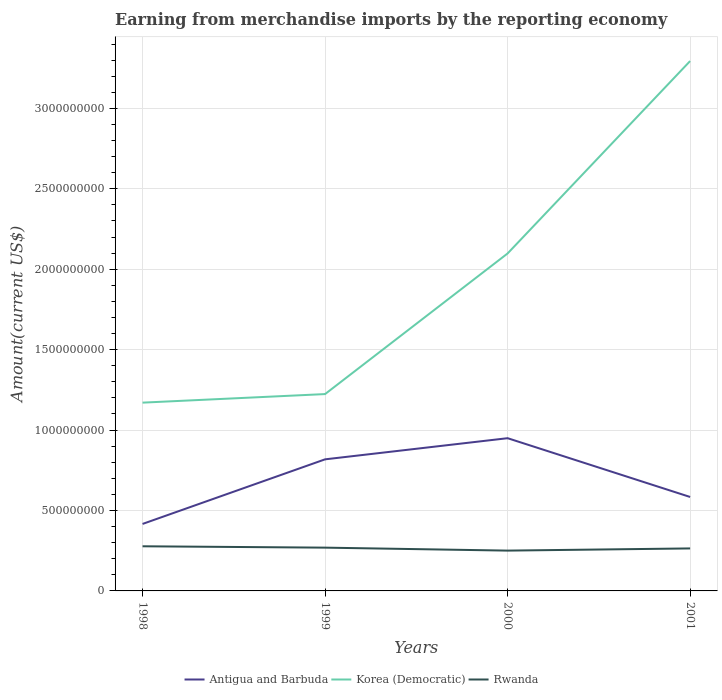How many different coloured lines are there?
Your answer should be compact. 3. Does the line corresponding to Antigua and Barbuda intersect with the line corresponding to Korea (Democratic)?
Your response must be concise. No. Across all years, what is the maximum amount earned from merchandise imports in Antigua and Barbuda?
Provide a short and direct response. 4.16e+08. In which year was the amount earned from merchandise imports in Antigua and Barbuda maximum?
Give a very brief answer. 1998. What is the total amount earned from merchandise imports in Korea (Democratic) in the graph?
Ensure brevity in your answer.  -1.20e+09. What is the difference between the highest and the second highest amount earned from merchandise imports in Korea (Democratic)?
Ensure brevity in your answer.  2.12e+09. What is the difference between the highest and the lowest amount earned from merchandise imports in Korea (Democratic)?
Ensure brevity in your answer.  2. Is the amount earned from merchandise imports in Korea (Democratic) strictly greater than the amount earned from merchandise imports in Antigua and Barbuda over the years?
Provide a succinct answer. No. How many years are there in the graph?
Your answer should be compact. 4. What is the difference between two consecutive major ticks on the Y-axis?
Your answer should be very brief. 5.00e+08. Are the values on the major ticks of Y-axis written in scientific E-notation?
Make the answer very short. No. Does the graph contain any zero values?
Your answer should be compact. No. Does the graph contain grids?
Your answer should be very brief. Yes. How many legend labels are there?
Provide a short and direct response. 3. How are the legend labels stacked?
Your answer should be compact. Horizontal. What is the title of the graph?
Provide a succinct answer. Earning from merchandise imports by the reporting economy. Does "Azerbaijan" appear as one of the legend labels in the graph?
Your answer should be compact. No. What is the label or title of the Y-axis?
Offer a terse response. Amount(current US$). What is the Amount(current US$) of Antigua and Barbuda in 1998?
Offer a terse response. 4.16e+08. What is the Amount(current US$) in Korea (Democratic) in 1998?
Provide a short and direct response. 1.17e+09. What is the Amount(current US$) of Rwanda in 1998?
Provide a succinct answer. 2.78e+08. What is the Amount(current US$) of Antigua and Barbuda in 1999?
Give a very brief answer. 8.18e+08. What is the Amount(current US$) of Korea (Democratic) in 1999?
Provide a succinct answer. 1.22e+09. What is the Amount(current US$) of Rwanda in 1999?
Your answer should be very brief. 2.69e+08. What is the Amount(current US$) of Antigua and Barbuda in 2000?
Keep it short and to the point. 9.50e+08. What is the Amount(current US$) of Korea (Democratic) in 2000?
Make the answer very short. 2.10e+09. What is the Amount(current US$) in Rwanda in 2000?
Offer a terse response. 2.51e+08. What is the Amount(current US$) of Antigua and Barbuda in 2001?
Provide a succinct answer. 5.84e+08. What is the Amount(current US$) of Korea (Democratic) in 2001?
Ensure brevity in your answer.  3.29e+09. What is the Amount(current US$) of Rwanda in 2001?
Offer a terse response. 2.64e+08. Across all years, what is the maximum Amount(current US$) in Antigua and Barbuda?
Offer a terse response. 9.50e+08. Across all years, what is the maximum Amount(current US$) of Korea (Democratic)?
Your answer should be compact. 3.29e+09. Across all years, what is the maximum Amount(current US$) of Rwanda?
Provide a short and direct response. 2.78e+08. Across all years, what is the minimum Amount(current US$) in Antigua and Barbuda?
Ensure brevity in your answer.  4.16e+08. Across all years, what is the minimum Amount(current US$) of Korea (Democratic)?
Your answer should be compact. 1.17e+09. Across all years, what is the minimum Amount(current US$) of Rwanda?
Provide a short and direct response. 2.51e+08. What is the total Amount(current US$) in Antigua and Barbuda in the graph?
Ensure brevity in your answer.  2.77e+09. What is the total Amount(current US$) of Korea (Democratic) in the graph?
Your response must be concise. 7.79e+09. What is the total Amount(current US$) of Rwanda in the graph?
Provide a succinct answer. 1.06e+09. What is the difference between the Amount(current US$) of Antigua and Barbuda in 1998 and that in 1999?
Offer a terse response. -4.02e+08. What is the difference between the Amount(current US$) of Korea (Democratic) in 1998 and that in 1999?
Keep it short and to the point. -5.33e+07. What is the difference between the Amount(current US$) of Rwanda in 1998 and that in 1999?
Offer a terse response. 8.50e+06. What is the difference between the Amount(current US$) of Antigua and Barbuda in 1998 and that in 2000?
Your response must be concise. -5.33e+08. What is the difference between the Amount(current US$) of Korea (Democratic) in 1998 and that in 2000?
Provide a short and direct response. -9.28e+08. What is the difference between the Amount(current US$) in Rwanda in 1998 and that in 2000?
Your answer should be compact. 2.69e+07. What is the difference between the Amount(current US$) in Antigua and Barbuda in 1998 and that in 2001?
Your answer should be compact. -1.68e+08. What is the difference between the Amount(current US$) in Korea (Democratic) in 1998 and that in 2001?
Provide a short and direct response. -2.12e+09. What is the difference between the Amount(current US$) in Rwanda in 1998 and that in 2001?
Your response must be concise. 1.33e+07. What is the difference between the Amount(current US$) of Antigua and Barbuda in 1999 and that in 2000?
Keep it short and to the point. -1.31e+08. What is the difference between the Amount(current US$) in Korea (Democratic) in 1999 and that in 2000?
Your response must be concise. -8.74e+08. What is the difference between the Amount(current US$) in Rwanda in 1999 and that in 2000?
Ensure brevity in your answer.  1.84e+07. What is the difference between the Amount(current US$) in Antigua and Barbuda in 1999 and that in 2001?
Offer a very short reply. 2.34e+08. What is the difference between the Amount(current US$) of Korea (Democratic) in 1999 and that in 2001?
Your answer should be very brief. -2.07e+09. What is the difference between the Amount(current US$) of Rwanda in 1999 and that in 2001?
Your response must be concise. 4.82e+06. What is the difference between the Amount(current US$) of Antigua and Barbuda in 2000 and that in 2001?
Offer a very short reply. 3.65e+08. What is the difference between the Amount(current US$) of Korea (Democratic) in 2000 and that in 2001?
Provide a short and direct response. -1.20e+09. What is the difference between the Amount(current US$) of Rwanda in 2000 and that in 2001?
Keep it short and to the point. -1.36e+07. What is the difference between the Amount(current US$) in Antigua and Barbuda in 1998 and the Amount(current US$) in Korea (Democratic) in 1999?
Give a very brief answer. -8.07e+08. What is the difference between the Amount(current US$) in Antigua and Barbuda in 1998 and the Amount(current US$) in Rwanda in 1999?
Make the answer very short. 1.47e+08. What is the difference between the Amount(current US$) of Korea (Democratic) in 1998 and the Amount(current US$) of Rwanda in 1999?
Ensure brevity in your answer.  9.02e+08. What is the difference between the Amount(current US$) in Antigua and Barbuda in 1998 and the Amount(current US$) in Korea (Democratic) in 2000?
Ensure brevity in your answer.  -1.68e+09. What is the difference between the Amount(current US$) of Antigua and Barbuda in 1998 and the Amount(current US$) of Rwanda in 2000?
Make the answer very short. 1.66e+08. What is the difference between the Amount(current US$) of Korea (Democratic) in 1998 and the Amount(current US$) of Rwanda in 2000?
Your response must be concise. 9.20e+08. What is the difference between the Amount(current US$) of Antigua and Barbuda in 1998 and the Amount(current US$) of Korea (Democratic) in 2001?
Offer a very short reply. -2.88e+09. What is the difference between the Amount(current US$) of Antigua and Barbuda in 1998 and the Amount(current US$) of Rwanda in 2001?
Provide a succinct answer. 1.52e+08. What is the difference between the Amount(current US$) of Korea (Democratic) in 1998 and the Amount(current US$) of Rwanda in 2001?
Make the answer very short. 9.06e+08. What is the difference between the Amount(current US$) of Antigua and Barbuda in 1999 and the Amount(current US$) of Korea (Democratic) in 2000?
Your answer should be compact. -1.28e+09. What is the difference between the Amount(current US$) in Antigua and Barbuda in 1999 and the Amount(current US$) in Rwanda in 2000?
Your answer should be compact. 5.67e+08. What is the difference between the Amount(current US$) in Korea (Democratic) in 1999 and the Amount(current US$) in Rwanda in 2000?
Give a very brief answer. 9.73e+08. What is the difference between the Amount(current US$) of Antigua and Barbuda in 1999 and the Amount(current US$) of Korea (Democratic) in 2001?
Ensure brevity in your answer.  -2.48e+09. What is the difference between the Amount(current US$) of Antigua and Barbuda in 1999 and the Amount(current US$) of Rwanda in 2001?
Keep it short and to the point. 5.54e+08. What is the difference between the Amount(current US$) in Korea (Democratic) in 1999 and the Amount(current US$) in Rwanda in 2001?
Your answer should be compact. 9.60e+08. What is the difference between the Amount(current US$) of Antigua and Barbuda in 2000 and the Amount(current US$) of Korea (Democratic) in 2001?
Provide a short and direct response. -2.34e+09. What is the difference between the Amount(current US$) of Antigua and Barbuda in 2000 and the Amount(current US$) of Rwanda in 2001?
Your answer should be compact. 6.85e+08. What is the difference between the Amount(current US$) of Korea (Democratic) in 2000 and the Amount(current US$) of Rwanda in 2001?
Give a very brief answer. 1.83e+09. What is the average Amount(current US$) in Antigua and Barbuda per year?
Ensure brevity in your answer.  6.92e+08. What is the average Amount(current US$) in Korea (Democratic) per year?
Offer a very short reply. 1.95e+09. What is the average Amount(current US$) of Rwanda per year?
Keep it short and to the point. 2.65e+08. In the year 1998, what is the difference between the Amount(current US$) of Antigua and Barbuda and Amount(current US$) of Korea (Democratic)?
Keep it short and to the point. -7.54e+08. In the year 1998, what is the difference between the Amount(current US$) of Antigua and Barbuda and Amount(current US$) of Rwanda?
Ensure brevity in your answer.  1.39e+08. In the year 1998, what is the difference between the Amount(current US$) of Korea (Democratic) and Amount(current US$) of Rwanda?
Make the answer very short. 8.93e+08. In the year 1999, what is the difference between the Amount(current US$) of Antigua and Barbuda and Amount(current US$) of Korea (Democratic)?
Ensure brevity in your answer.  -4.06e+08. In the year 1999, what is the difference between the Amount(current US$) in Antigua and Barbuda and Amount(current US$) in Rwanda?
Your answer should be very brief. 5.49e+08. In the year 1999, what is the difference between the Amount(current US$) in Korea (Democratic) and Amount(current US$) in Rwanda?
Keep it short and to the point. 9.55e+08. In the year 2000, what is the difference between the Amount(current US$) of Antigua and Barbuda and Amount(current US$) of Korea (Democratic)?
Offer a very short reply. -1.15e+09. In the year 2000, what is the difference between the Amount(current US$) in Antigua and Barbuda and Amount(current US$) in Rwanda?
Provide a succinct answer. 6.99e+08. In the year 2000, what is the difference between the Amount(current US$) in Korea (Democratic) and Amount(current US$) in Rwanda?
Offer a very short reply. 1.85e+09. In the year 2001, what is the difference between the Amount(current US$) of Antigua and Barbuda and Amount(current US$) of Korea (Democratic)?
Your answer should be compact. -2.71e+09. In the year 2001, what is the difference between the Amount(current US$) of Antigua and Barbuda and Amount(current US$) of Rwanda?
Offer a very short reply. 3.20e+08. In the year 2001, what is the difference between the Amount(current US$) of Korea (Democratic) and Amount(current US$) of Rwanda?
Provide a succinct answer. 3.03e+09. What is the ratio of the Amount(current US$) of Antigua and Barbuda in 1998 to that in 1999?
Give a very brief answer. 0.51. What is the ratio of the Amount(current US$) of Korea (Democratic) in 1998 to that in 1999?
Provide a succinct answer. 0.96. What is the ratio of the Amount(current US$) in Rwanda in 1998 to that in 1999?
Give a very brief answer. 1.03. What is the ratio of the Amount(current US$) in Antigua and Barbuda in 1998 to that in 2000?
Keep it short and to the point. 0.44. What is the ratio of the Amount(current US$) of Korea (Democratic) in 1998 to that in 2000?
Provide a succinct answer. 0.56. What is the ratio of the Amount(current US$) of Rwanda in 1998 to that in 2000?
Make the answer very short. 1.11. What is the ratio of the Amount(current US$) of Antigua and Barbuda in 1998 to that in 2001?
Your answer should be compact. 0.71. What is the ratio of the Amount(current US$) in Korea (Democratic) in 1998 to that in 2001?
Keep it short and to the point. 0.36. What is the ratio of the Amount(current US$) of Rwanda in 1998 to that in 2001?
Your answer should be compact. 1.05. What is the ratio of the Amount(current US$) in Antigua and Barbuda in 1999 to that in 2000?
Make the answer very short. 0.86. What is the ratio of the Amount(current US$) of Korea (Democratic) in 1999 to that in 2000?
Your answer should be very brief. 0.58. What is the ratio of the Amount(current US$) in Rwanda in 1999 to that in 2000?
Provide a short and direct response. 1.07. What is the ratio of the Amount(current US$) of Antigua and Barbuda in 1999 to that in 2001?
Provide a short and direct response. 1.4. What is the ratio of the Amount(current US$) of Korea (Democratic) in 1999 to that in 2001?
Make the answer very short. 0.37. What is the ratio of the Amount(current US$) of Rwanda in 1999 to that in 2001?
Offer a terse response. 1.02. What is the ratio of the Amount(current US$) of Antigua and Barbuda in 2000 to that in 2001?
Provide a succinct answer. 1.63. What is the ratio of the Amount(current US$) in Korea (Democratic) in 2000 to that in 2001?
Offer a very short reply. 0.64. What is the ratio of the Amount(current US$) in Rwanda in 2000 to that in 2001?
Your response must be concise. 0.95. What is the difference between the highest and the second highest Amount(current US$) in Antigua and Barbuda?
Ensure brevity in your answer.  1.31e+08. What is the difference between the highest and the second highest Amount(current US$) of Korea (Democratic)?
Your response must be concise. 1.20e+09. What is the difference between the highest and the second highest Amount(current US$) of Rwanda?
Make the answer very short. 8.50e+06. What is the difference between the highest and the lowest Amount(current US$) of Antigua and Barbuda?
Keep it short and to the point. 5.33e+08. What is the difference between the highest and the lowest Amount(current US$) in Korea (Democratic)?
Offer a terse response. 2.12e+09. What is the difference between the highest and the lowest Amount(current US$) in Rwanda?
Keep it short and to the point. 2.69e+07. 